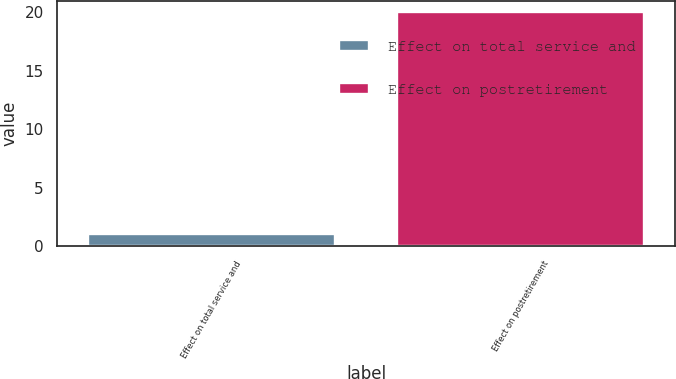Convert chart to OTSL. <chart><loc_0><loc_0><loc_500><loc_500><bar_chart><fcel>Effect on total service and<fcel>Effect on postretirement<nl><fcel>1<fcel>20<nl></chart> 